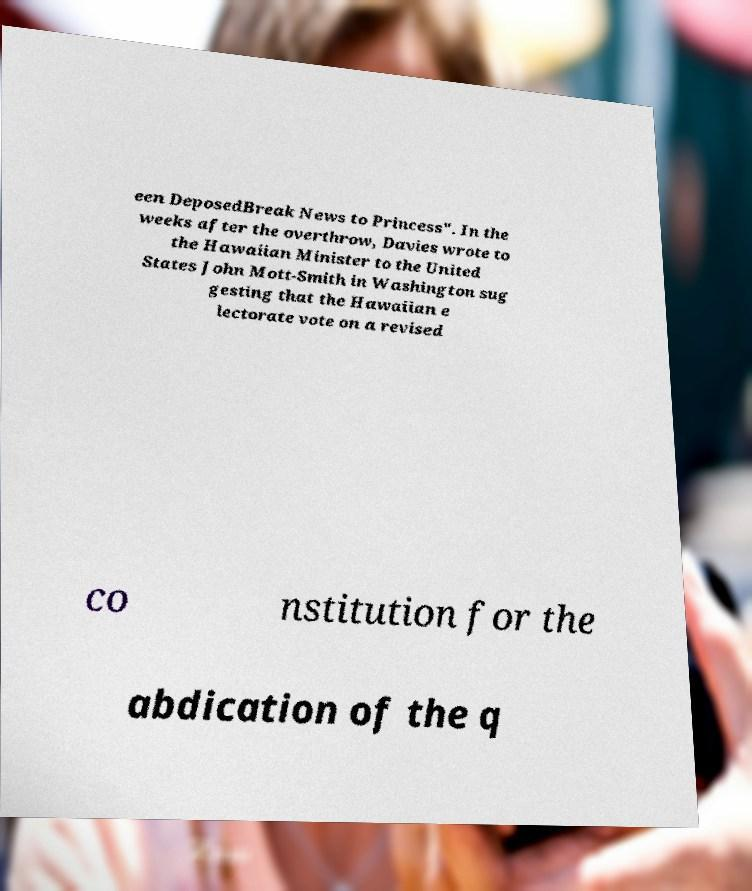There's text embedded in this image that I need extracted. Can you transcribe it verbatim? een DeposedBreak News to Princess". In the weeks after the overthrow, Davies wrote to the Hawaiian Minister to the United States John Mott-Smith in Washington sug gesting that the Hawaiian e lectorate vote on a revised co nstitution for the abdication of the q 